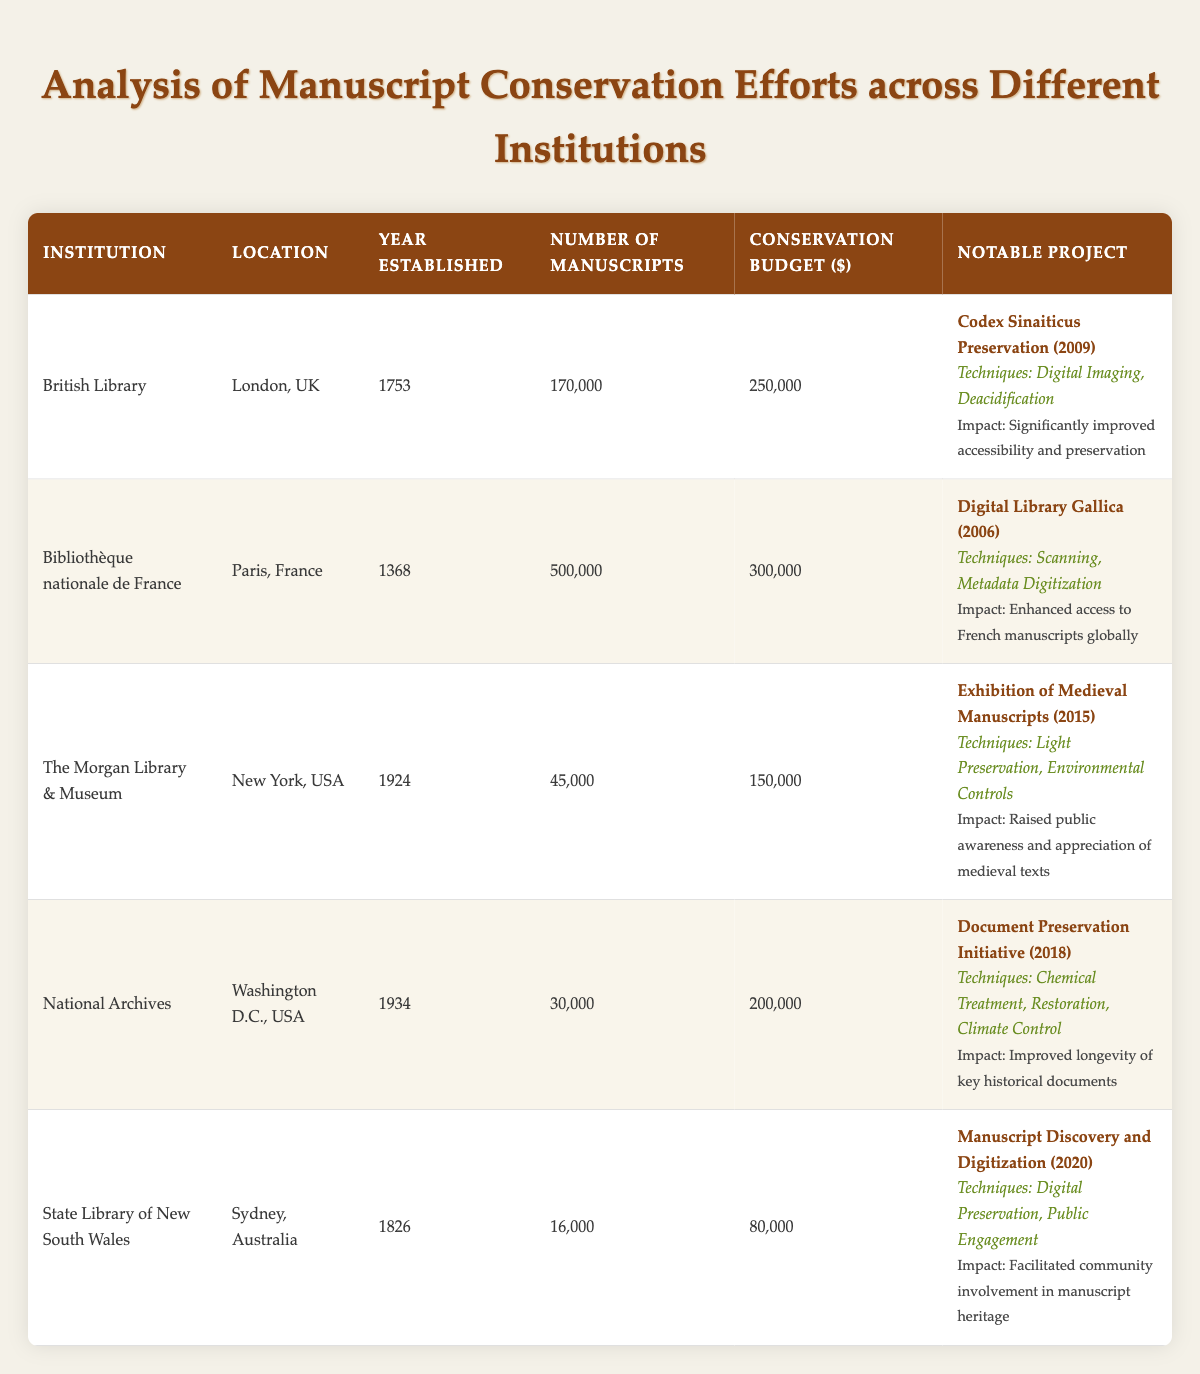What is the conservation budget of the British Library? The conservation budget for the British Library is listed in the table as $250,000.
Answer: $250,000 Which institution has the highest number of manuscripts? The institution with the highest number of manuscripts is the Bibliothèque nationale de France, which has 500,000 manuscripts.
Answer: Bibliothèque nationale de France What techniques were used in the Codex Sinaiticus Preservation project? The table lists the techniques used in the Codex Sinaiticus Preservation project as Digital Imaging and Deacidification.
Answer: Digital Imaging, Deacidification What is the average conservation budget across all institutions? To calculate the average conservation budget, we sum the budgets: $250,000 + $300,000 + $150,000 + $200,000 + $80,000 = $980,000; then divide by the number of institutions (5): $980,000 / 5 = $196,000.
Answer: $196,000 Is the National Archives conservation budget higher than the state library of New South Wales? Yes, the National Archives has a conservation budget of $200,000, which is higher than the $80,000 budget of the State Library of New South Wales.
Answer: Yes Which project aimed to enhance access to French manuscripts globally? The project that aimed to enhance access to French manuscripts globally is the Digital Library Gallica, completed in 2006 by the Bibliothèque nationale de France.
Answer: Digital Library Gallica How many manuscripts does the State Library of New South Wales have? The State Library of New South Wales has 16,000 manuscripts, as indicated in the table.
Answer: 16,000 What was the impact of the Document Preservation Initiative? The impact of the Document Preservation Initiative was to improve the longevity of key historical documents, as stated in the table.
Answer: Improved longevity of key historical documents How many more manuscripts does the British Library have compared to The Morgan Library & Museum? The British Library has 170,000 manuscripts, while The Morgan Library & Museum has 45,000 manuscripts. The difference is 170,000 - 45,000 = 125,000 manuscripts.
Answer: 125,000 